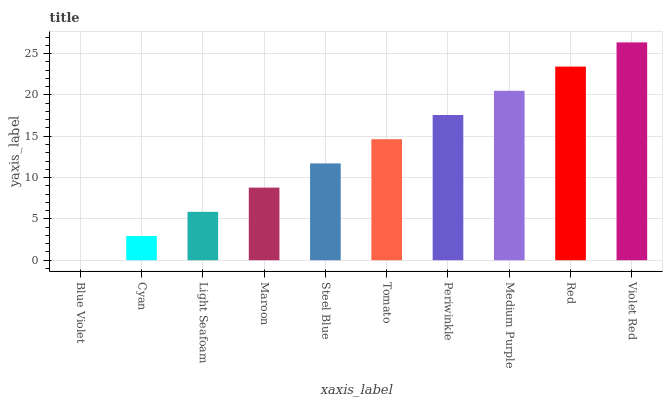Is Blue Violet the minimum?
Answer yes or no. Yes. Is Violet Red the maximum?
Answer yes or no. Yes. Is Cyan the minimum?
Answer yes or no. No. Is Cyan the maximum?
Answer yes or no. No. Is Cyan greater than Blue Violet?
Answer yes or no. Yes. Is Blue Violet less than Cyan?
Answer yes or no. Yes. Is Blue Violet greater than Cyan?
Answer yes or no. No. Is Cyan less than Blue Violet?
Answer yes or no. No. Is Tomato the high median?
Answer yes or no. Yes. Is Steel Blue the low median?
Answer yes or no. Yes. Is Light Seafoam the high median?
Answer yes or no. No. Is Maroon the low median?
Answer yes or no. No. 